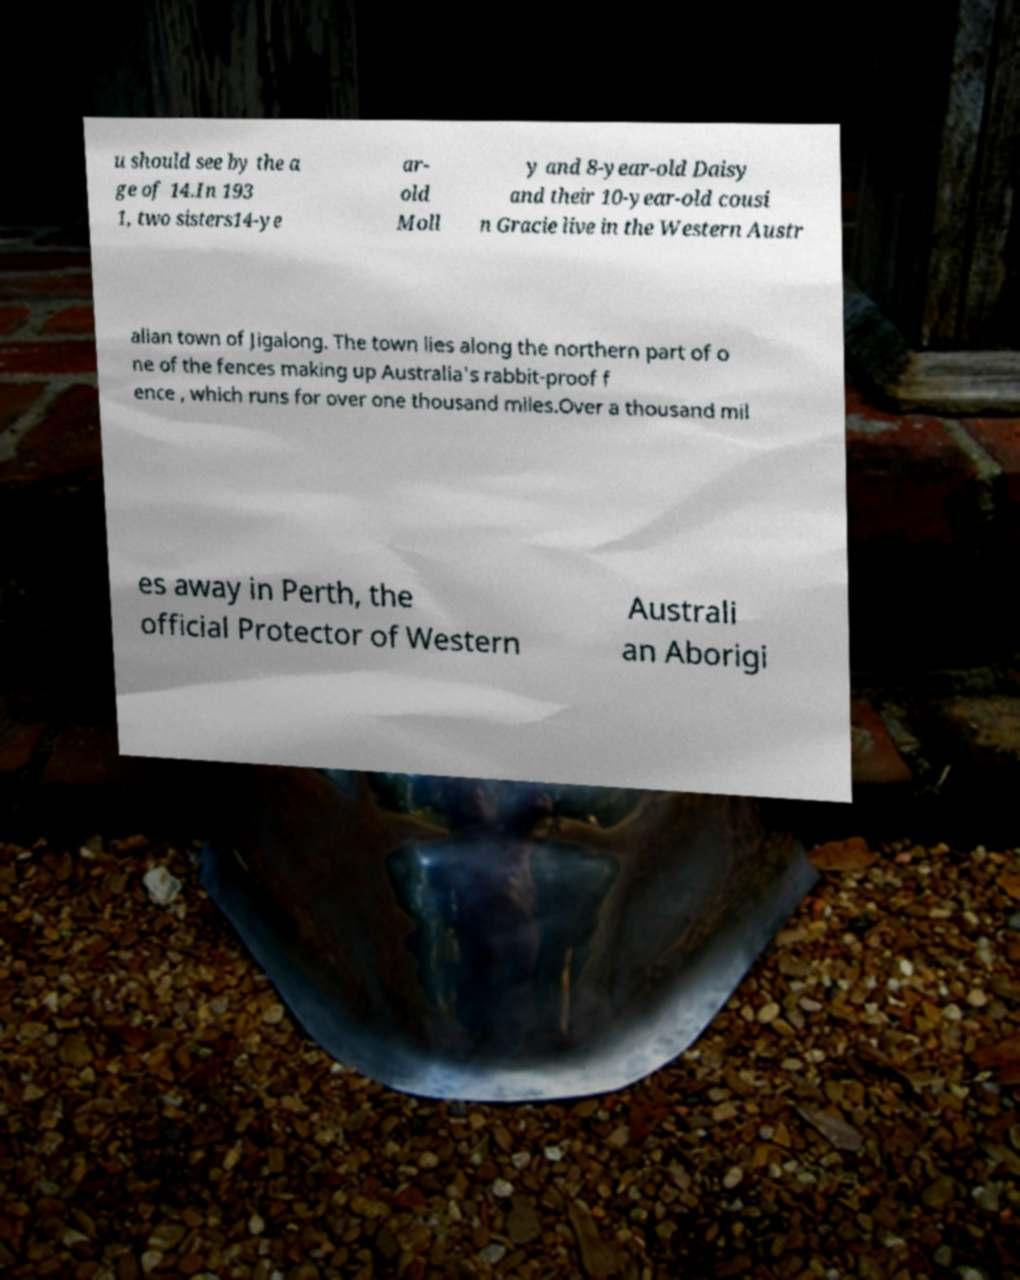Could you extract and type out the text from this image? u should see by the a ge of 14.In 193 1, two sisters14-ye ar- old Moll y and 8-year-old Daisy and their 10-year-old cousi n Gracie live in the Western Austr alian town of Jigalong. The town lies along the northern part of o ne of the fences making up Australia's rabbit-proof f ence , which runs for over one thousand miles.Over a thousand mil es away in Perth, the official Protector of Western Australi an Aborigi 